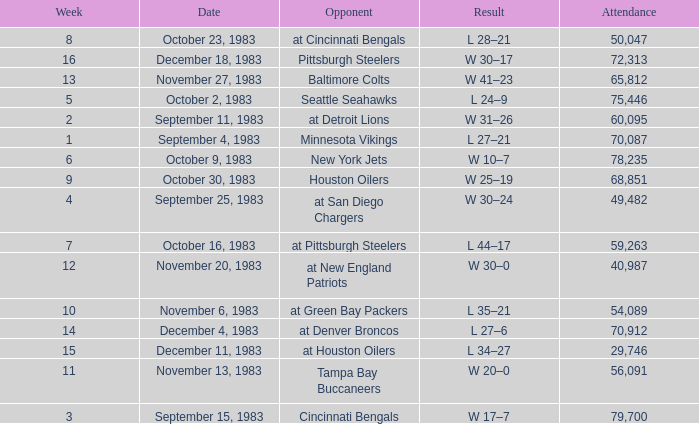What is the average attendance after week 16? None. 